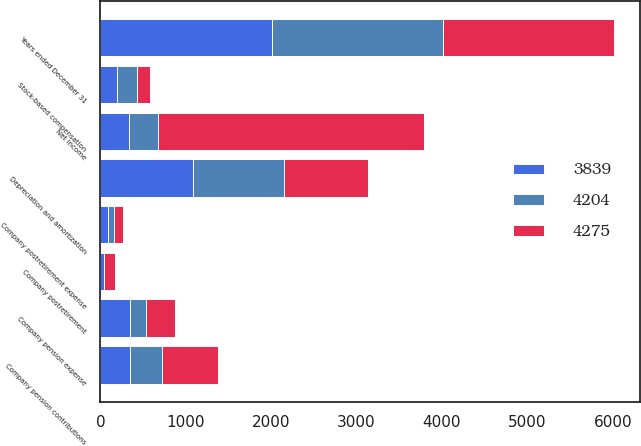Convert chart. <chart><loc_0><loc_0><loc_500><loc_500><stacked_bar_chart><ecel><fcel>Years ended December 31<fcel>Net income<fcel>Depreciation and amortization<fcel>Company pension contributions<fcel>Company postretirement<fcel>Company pension expense<fcel>Company postretirement expense<fcel>Stock-based compensation<nl><fcel>4204<fcel>2007<fcel>339<fcel>1072<fcel>376<fcel>3<fcel>190<fcel>65<fcel>228<nl><fcel>3839<fcel>2006<fcel>339<fcel>1079<fcel>348<fcel>37<fcel>347<fcel>93<fcel>200<nl><fcel>4275<fcel>2005<fcel>3111<fcel>986<fcel>654<fcel>134<fcel>331<fcel>106<fcel>155<nl></chart> 